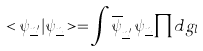Convert formula to latex. <formula><loc_0><loc_0><loc_500><loc_500>< \psi _ { { \underline { n } } ^ { \prime } } | \psi _ { \underline { n } } > = \int { \overline { \psi } } _ { { \underline { n } } ^ { \prime } } \, \psi _ { \underline { n } } \prod d g _ { l }</formula> 